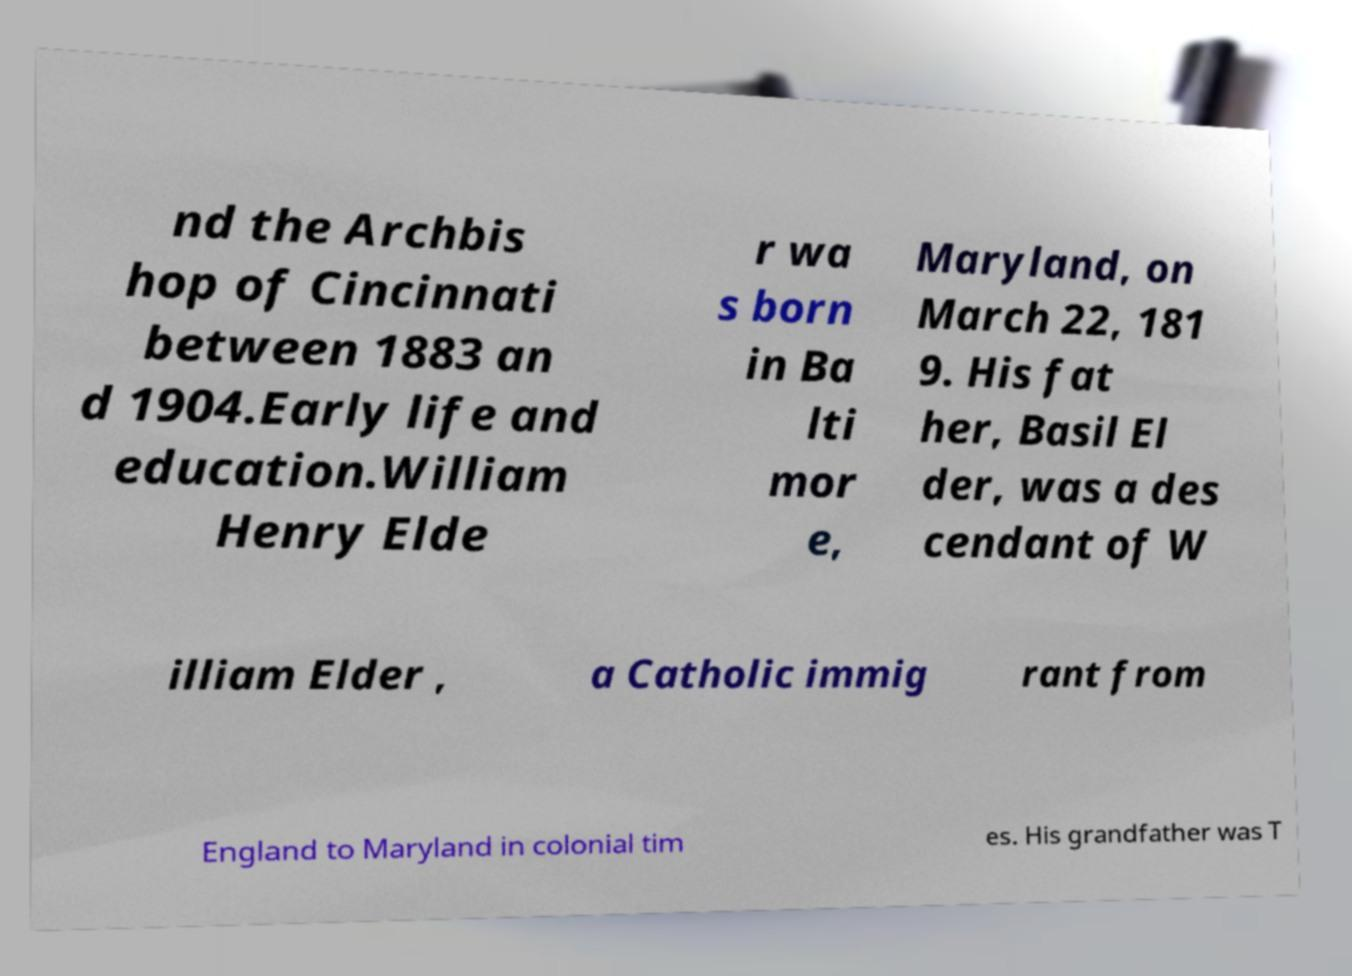Can you accurately transcribe the text from the provided image for me? nd the Archbis hop of Cincinnati between 1883 an d 1904.Early life and education.William Henry Elde r wa s born in Ba lti mor e, Maryland, on March 22, 181 9. His fat her, Basil El der, was a des cendant of W illiam Elder , a Catholic immig rant from England to Maryland in colonial tim es. His grandfather was T 